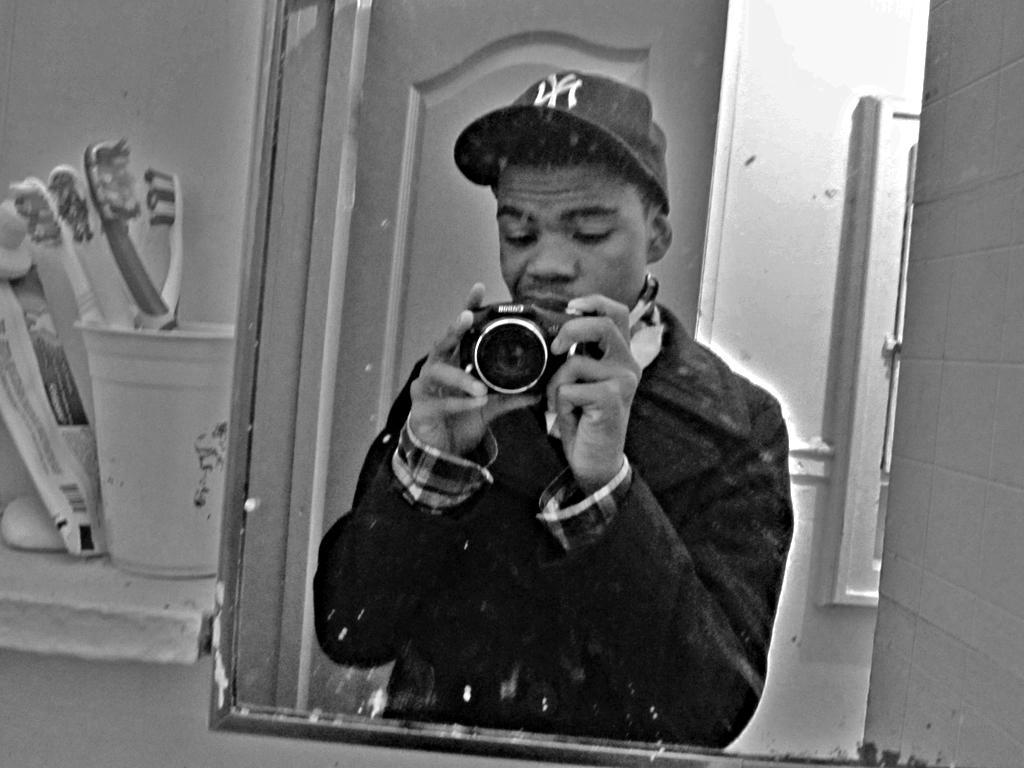In one or two sentences, can you explain what this image depicts? This is a black and white picture. I can see a mirror, there is a reflection of a man standing and holding a camera, there is a door, there are toothbrushes in a glass, there is a tube and an object on the cement shelf. 